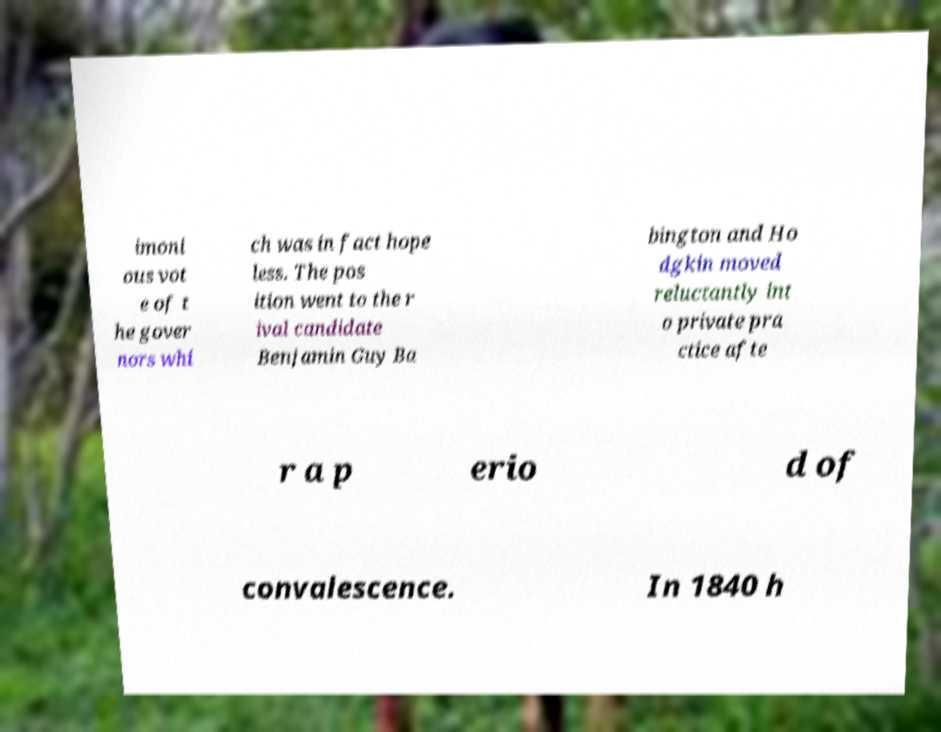For documentation purposes, I need the text within this image transcribed. Could you provide that? imoni ous vot e of t he gover nors whi ch was in fact hope less. The pos ition went to the r ival candidate Benjamin Guy Ba bington and Ho dgkin moved reluctantly int o private pra ctice afte r a p erio d of convalescence. In 1840 h 